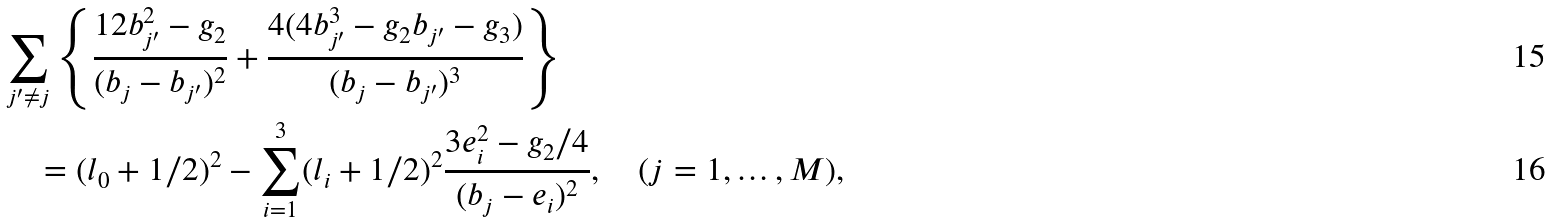Convert formula to latex. <formula><loc_0><loc_0><loc_500><loc_500>& \sum _ { j ^ { \prime } \neq j } \left \{ \frac { 1 2 b _ { j ^ { \prime } } ^ { 2 } - g _ { 2 } } { ( b _ { j } - b _ { j ^ { \prime } } ) ^ { 2 } } + \frac { 4 ( 4 b _ { j ^ { \prime } } ^ { 3 } - g _ { 2 } b _ { j ^ { \prime } } - g _ { 3 } ) } { ( b _ { j } - b _ { j ^ { \prime } } ) ^ { 3 } } \right \} \\ & \quad = ( l _ { 0 } + 1 / 2 ) ^ { 2 } - \sum _ { i = 1 } ^ { 3 } ( l _ { i } + 1 / 2 ) ^ { 2 } \frac { 3 e _ { i } ^ { 2 } - g _ { 2 } / 4 } { ( b _ { j } - e _ { i } ) ^ { 2 } } , \quad ( j = 1 , \dots , M ) ,</formula> 